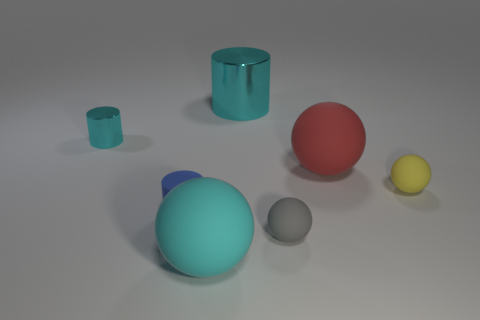What is the size of the red matte object that is the same shape as the tiny gray rubber object?
Offer a very short reply. Large. The big metallic thing is what shape?
Your answer should be compact. Cylinder. Do the tiny cyan thing and the large cyan object that is behind the gray sphere have the same material?
Make the answer very short. Yes. How many matte objects are either red things or big yellow objects?
Your answer should be compact. 1. What is the size of the object in front of the gray object?
Keep it short and to the point. Large. There is a gray sphere that is made of the same material as the large red object; what is its size?
Provide a short and direct response. Small. What number of other metallic objects have the same color as the large metal object?
Make the answer very short. 1. Are any cyan spheres visible?
Keep it short and to the point. Yes. There is a gray rubber object; does it have the same shape as the metallic object left of the blue matte cylinder?
Offer a terse response. No. What is the color of the cylinder that is behind the cyan thing left of the cylinder in front of the small yellow thing?
Provide a succinct answer. Cyan. 